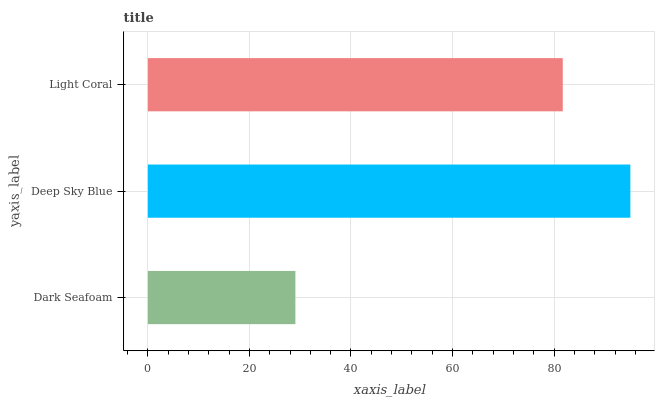Is Dark Seafoam the minimum?
Answer yes or no. Yes. Is Deep Sky Blue the maximum?
Answer yes or no. Yes. Is Light Coral the minimum?
Answer yes or no. No. Is Light Coral the maximum?
Answer yes or no. No. Is Deep Sky Blue greater than Light Coral?
Answer yes or no. Yes. Is Light Coral less than Deep Sky Blue?
Answer yes or no. Yes. Is Light Coral greater than Deep Sky Blue?
Answer yes or no. No. Is Deep Sky Blue less than Light Coral?
Answer yes or no. No. Is Light Coral the high median?
Answer yes or no. Yes. Is Light Coral the low median?
Answer yes or no. Yes. Is Deep Sky Blue the high median?
Answer yes or no. No. Is Dark Seafoam the low median?
Answer yes or no. No. 